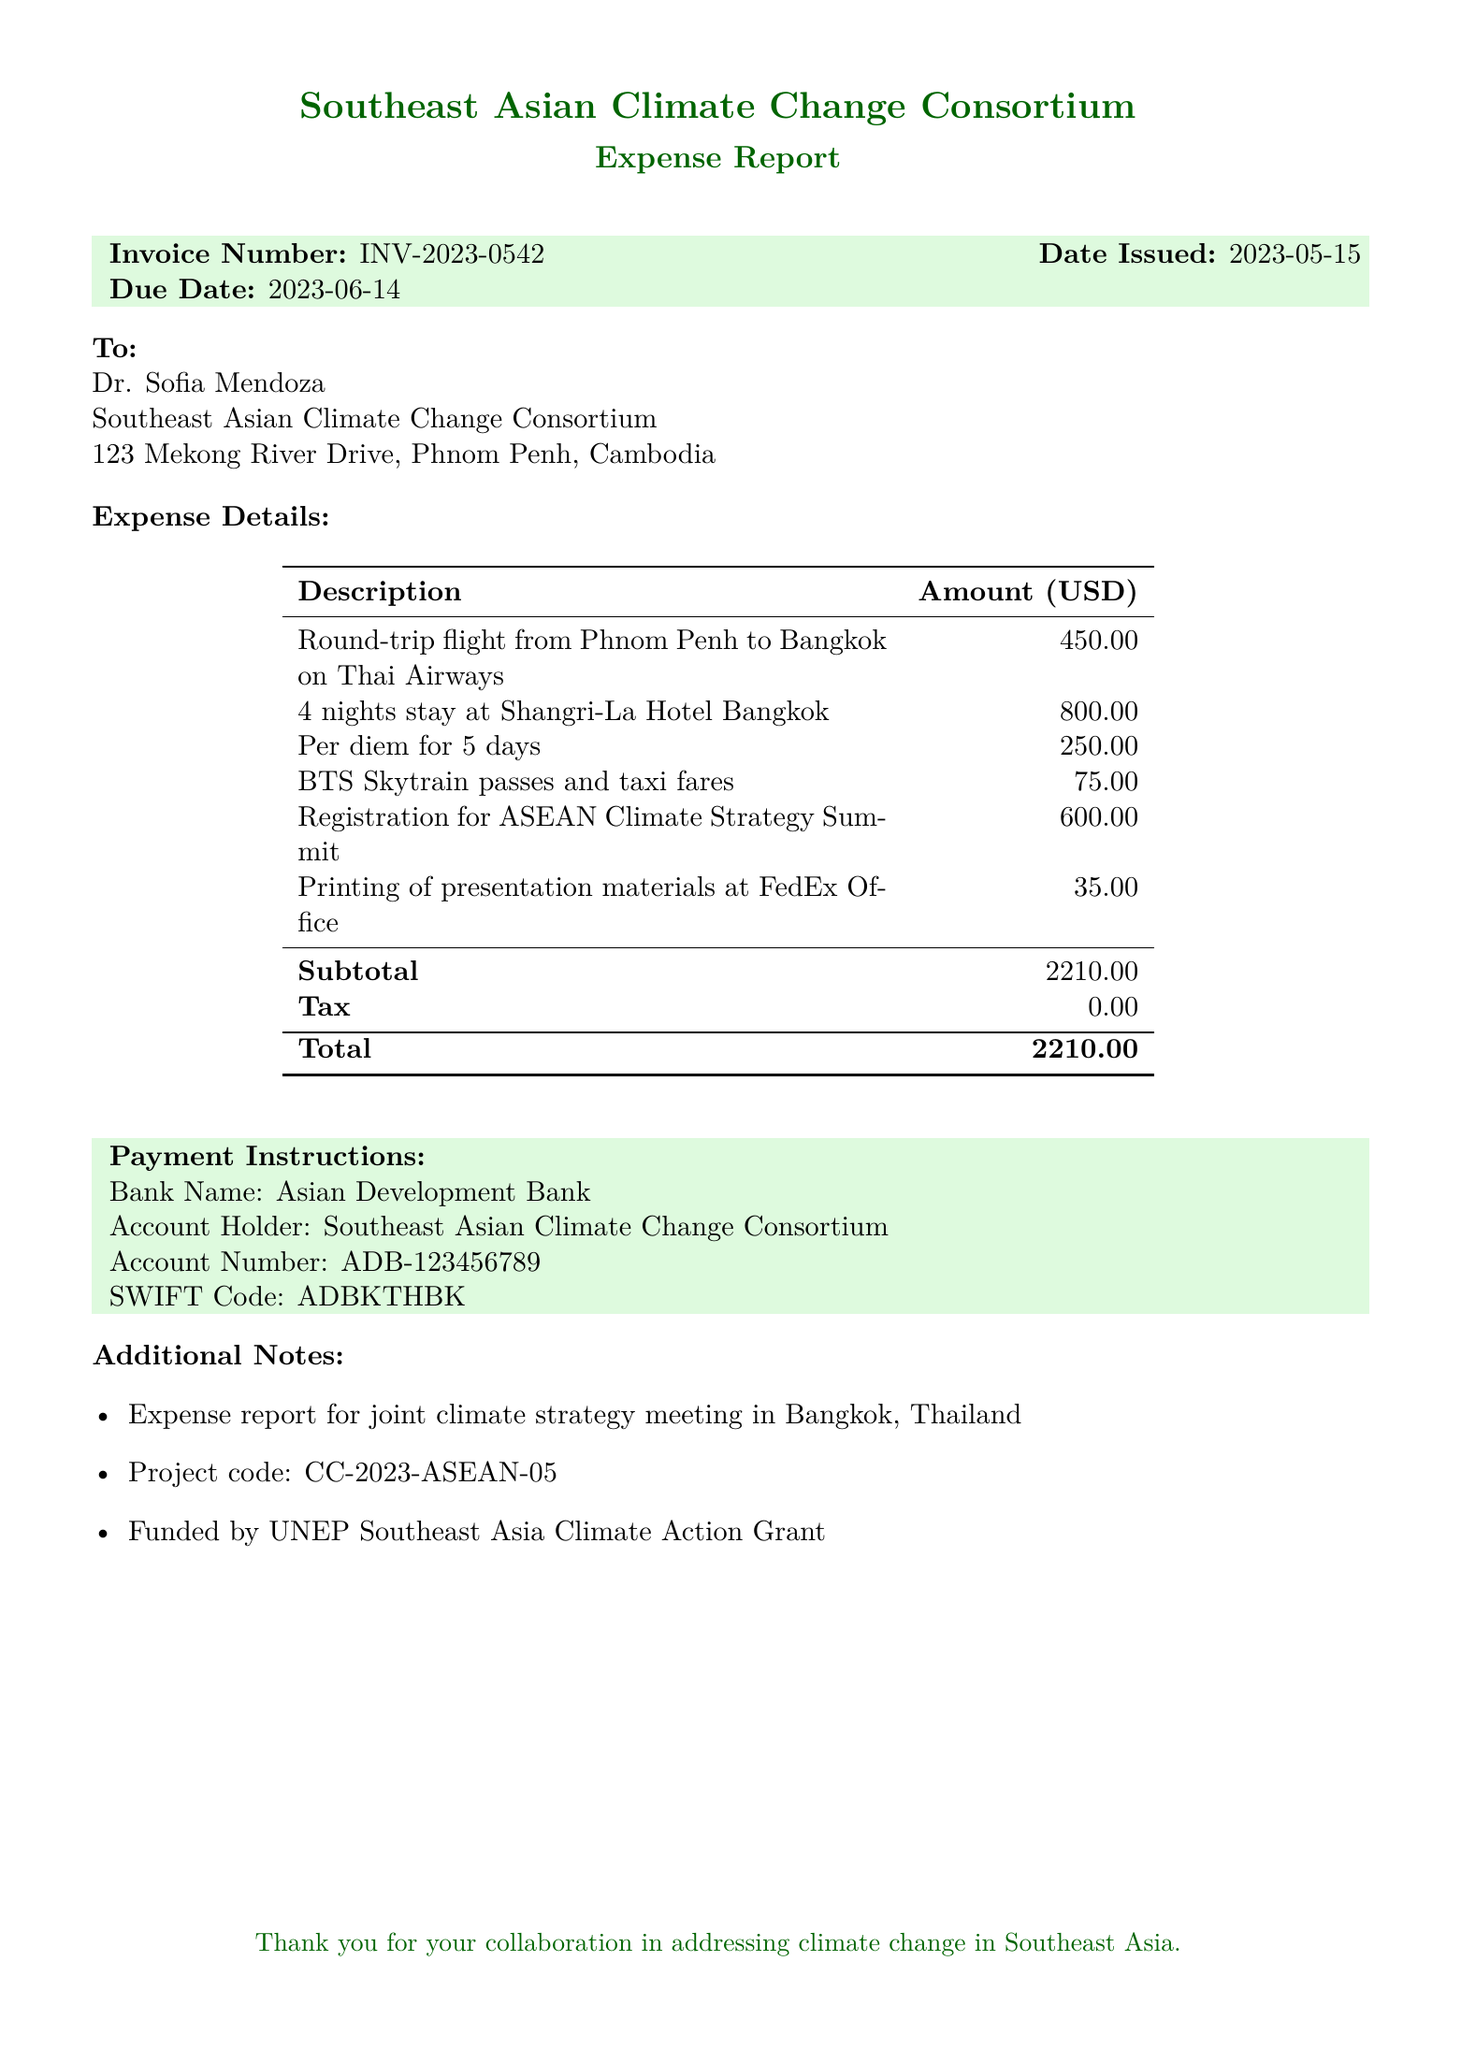What is the invoice number? The invoice number is stated at the top of the document as INV-2023-0542.
Answer: INV-2023-0542 Who is the client? The client is Dr. Sofia Mendoza from the Southeast Asian Climate Change Consortium.
Answer: Dr. Sofia Mendoza What is the total amount due? The total amount due is calculated as the subtotal plus tax, which totals to 2210.00 USD.
Answer: 2210.00 USD When was the invoice issued? The date issued for the invoice is clearly listed as 2023-05-15.
Answer: 2023-05-15 What is the project code? The project code is provided in the additional notes section, which is CC-2023-ASEAN-05.
Answer: CC-2023-ASEAN-05 What is the accommodation cost? The cost for accommodation, specifically for the Shangri-La Hotel in Bangkok, is mentioned as 800.00 USD.
Answer: 800.00 USD What are the payment instructions bank details? The payment instructions include the bank name Asian Development Bank along with the other banking details.
Answer: Asian Development Bank How many nights was the accommodation for? The accommodation was for 4 nights, as mentioned in the description.
Answer: 4 nights What type of event did this expense report cover? The expense report is associated with the ASEAN Climate Strategy Summit.
Answer: ASEAN Climate Strategy Summit 